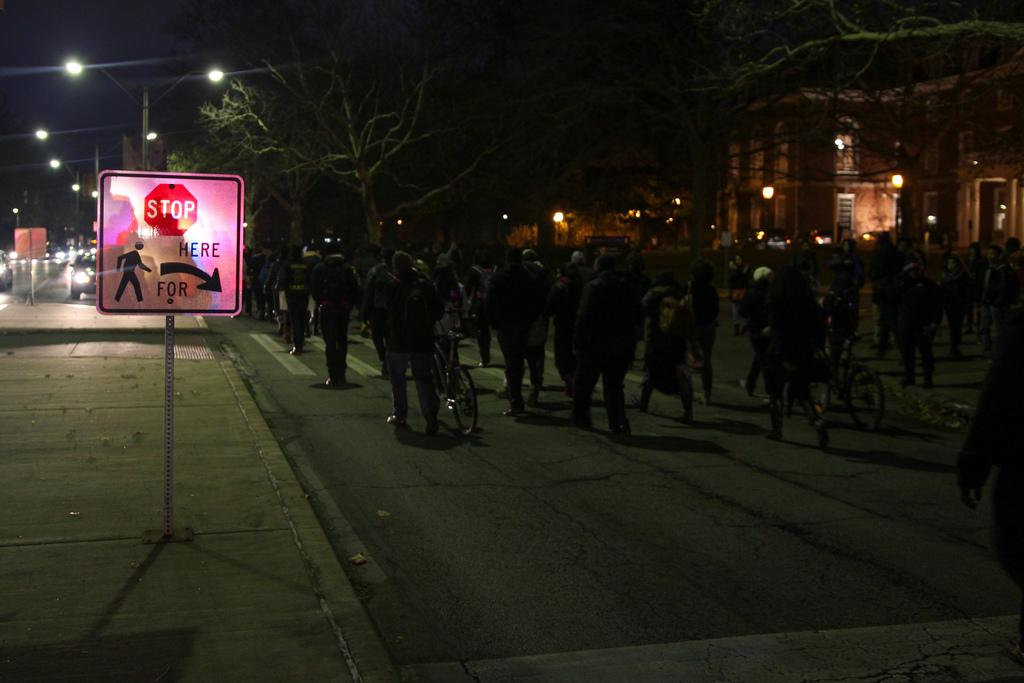What can be seen on the left side of the image? There are signboards, light poles, and vehicles on the left side of the image. What is happening in the middle and right side of the image? There are people, bicycles, buildings, and trees in the middle and right side of the image. Can you tell me what the snails are discussing in the image? There are no snails present in the image, so it is not possible to determine what they might be discussing. 